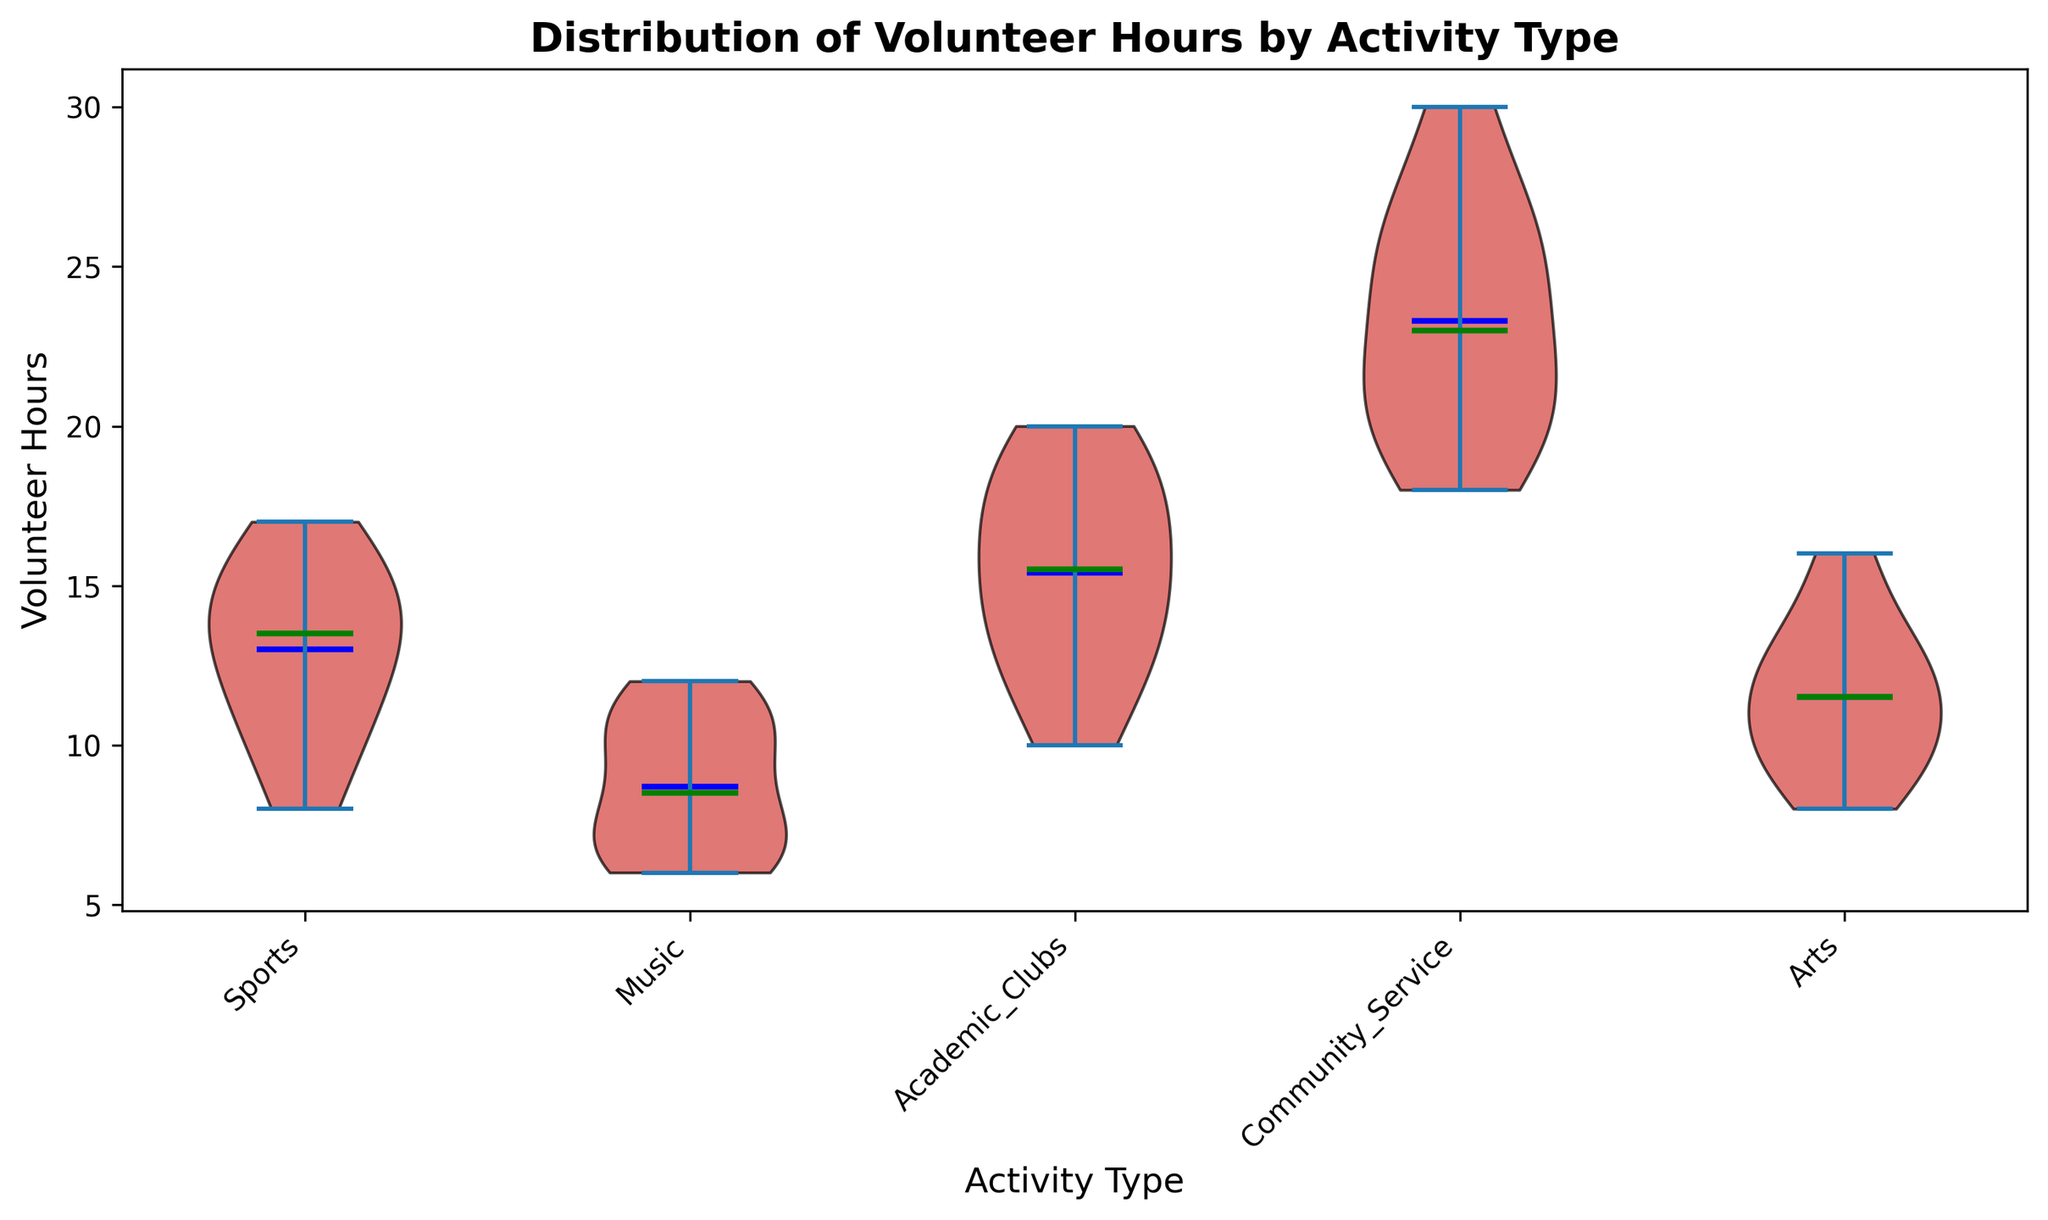What does the violin plot represent? The violin plot visualizes the distribution of volunteer hours among students for different types of extracurricular activities, showing the density of the data and highlighting the mean and median values for each activity type.
Answer: It represents the distribution of volunteer hours for different activities Which activity type has the highest median volunteer hours? To find the activity with the highest median, look at the green line (indicating the median) inside each violin shape. The highest median line appears in "Community_Service".
Answer: Community_Service Which activity type has the widest range of volunteer hours? The range is represented by the span of each violin shape on the y-axis. "Community_Service" has the widest range, as its shape extends the most on the y-axis.
Answer: Community_Service What are the median volunteer hours for 'Music' and 'Academic_Clubs'? To determine this, locate the green lines inside the 'Music' and 'Academic_Clubs' violins. 'Music' median is approximately 9 hours, and 'Academic_Clubs' median is approximately 15 hours.
Answer: Music: 9, Academic_Clubs: 15 Which activity type has the lowest mean volunteer hours? The blue line inside each violin shape represents the mean. The lowest mean line appears in "Music".
Answer: Music Compare the median volunteer hours of 'Sports' to 'Arts'. Which is higher and by how much? Locate the green lines in 'Sports' and 'Arts' violins. 'Sports' median is approximately 13.5 and 'Arts' is approximately 11.5 hours. Subtract the 'Arts' median from 'Sports' median to find the difference.
Answer: Sports is higher by 2 hours How does the distribution of volunteer hours in 'Academic_Clubs' compare to 'Music'? 'Academic_Clubs' has a wider and higher spread, with a higher median and mean compared to 'Music', which has a narrower shape indicating fewer hours centralized around the median.
Answer: Academic_Clubs has a wider and higher spread What can you infer about the volunteer hours in 'Community_Service'? The 'Community_Service' violin plot shows a wide spread indicating high variability, with high median and mean values suggesting students in this activity type volunteer more hours.
Answer: High variability and high volunteer hours Which activity displays the most consistent volunteer hours? Consistency is indicated by the narrowest spread on the y-axis. 'Music' and 'Arts' both have relatively narrow spreads, indicating more consistent volunteer hours.
Answer: Music and Arts How does the mean volunteer hours for 'Sports' compare to the median volunteer hours of 'Arts'? Locate the blue mean line in 'Sports' and the green median line in 'Arts'. 'Sports' mean is approximately 13.5 and 'Arts' median is approximately 11.5 hours. Compare these two values directly.
Answer: Sports mean is higher by approximately 2 hours 